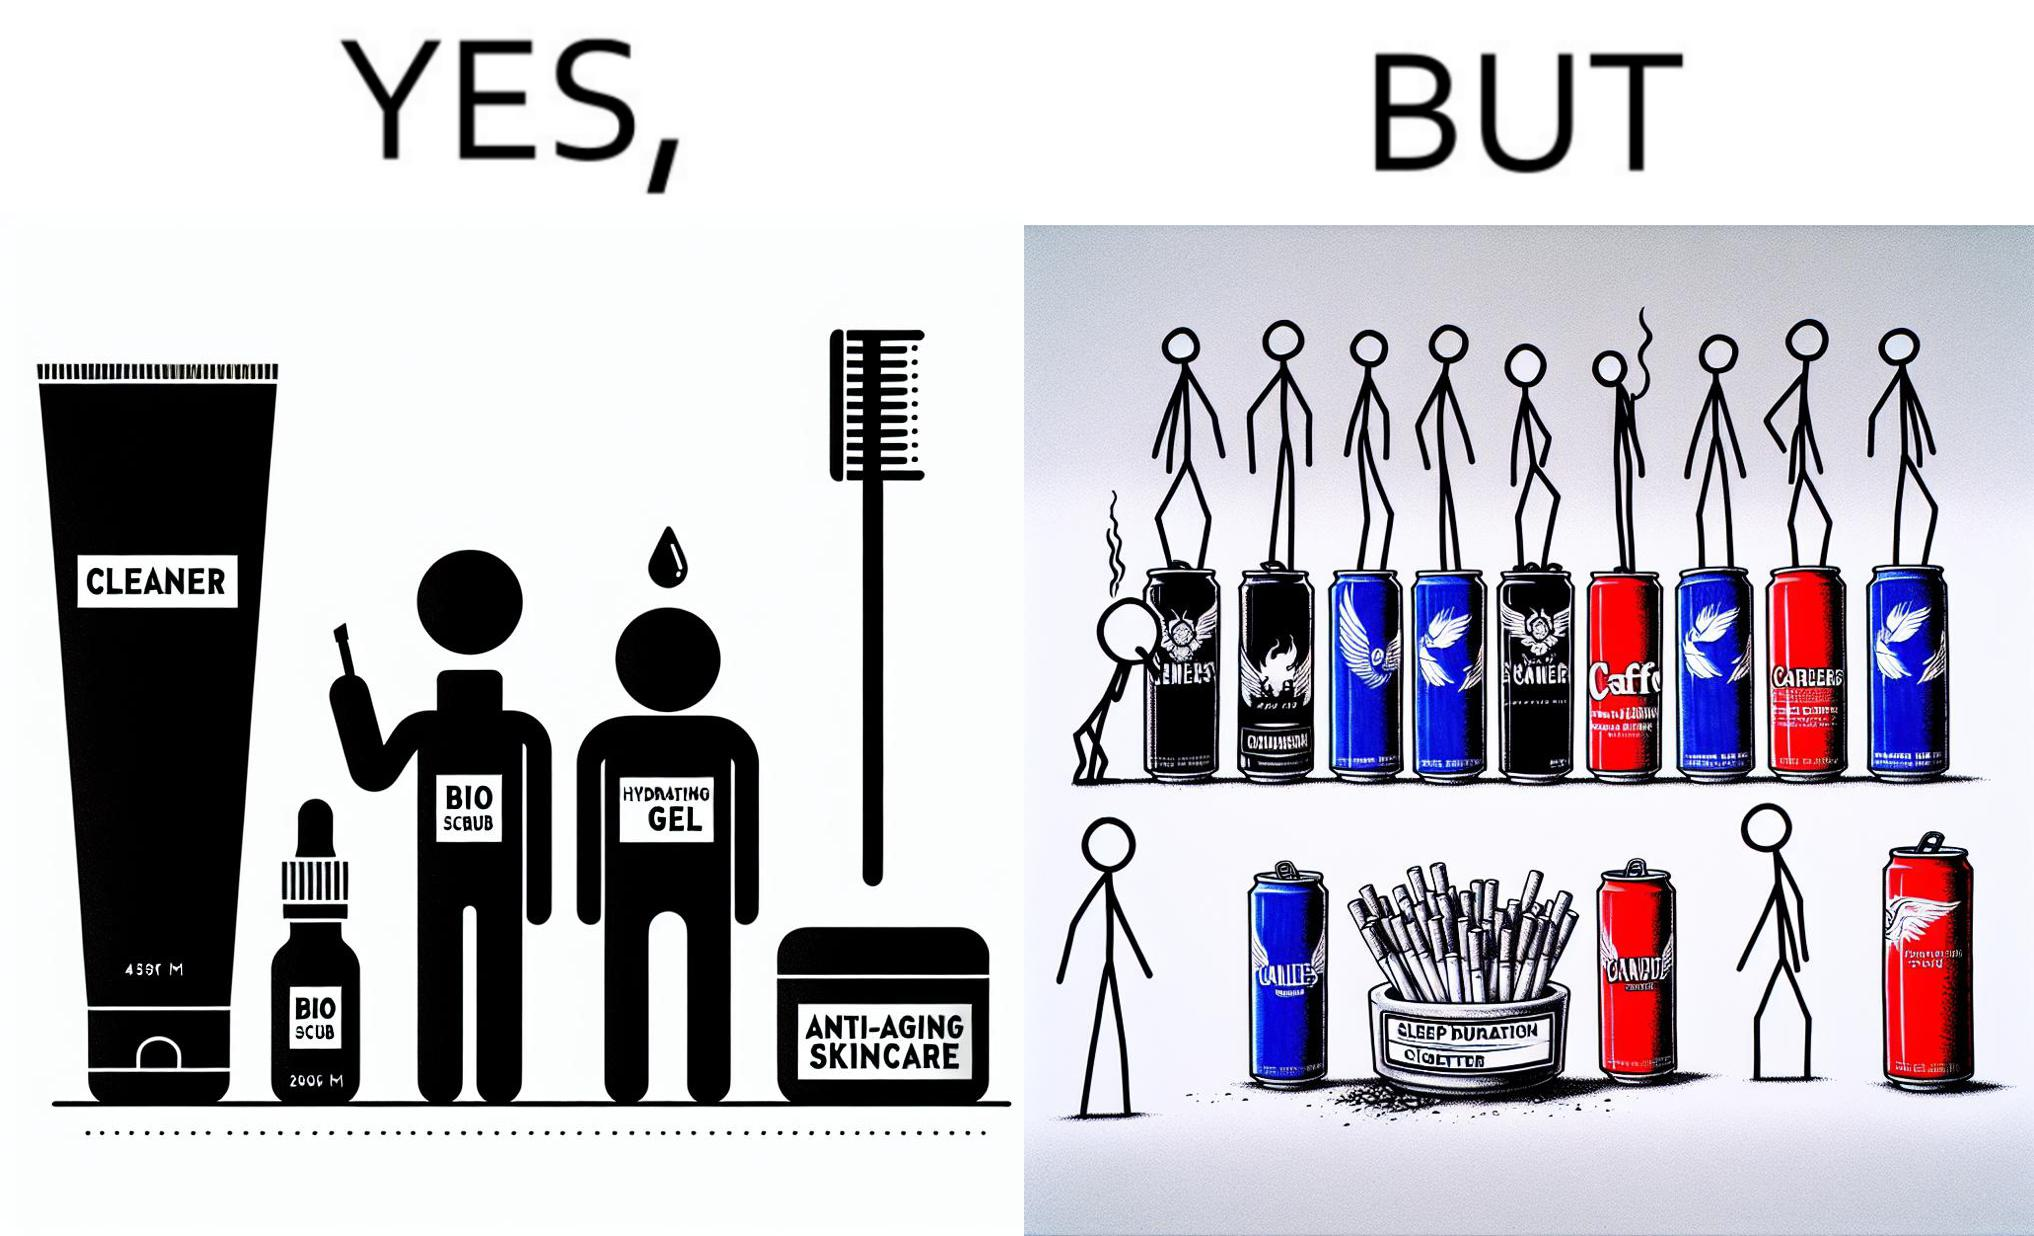Is there satirical content in this image? Yes, this image is satirical. 